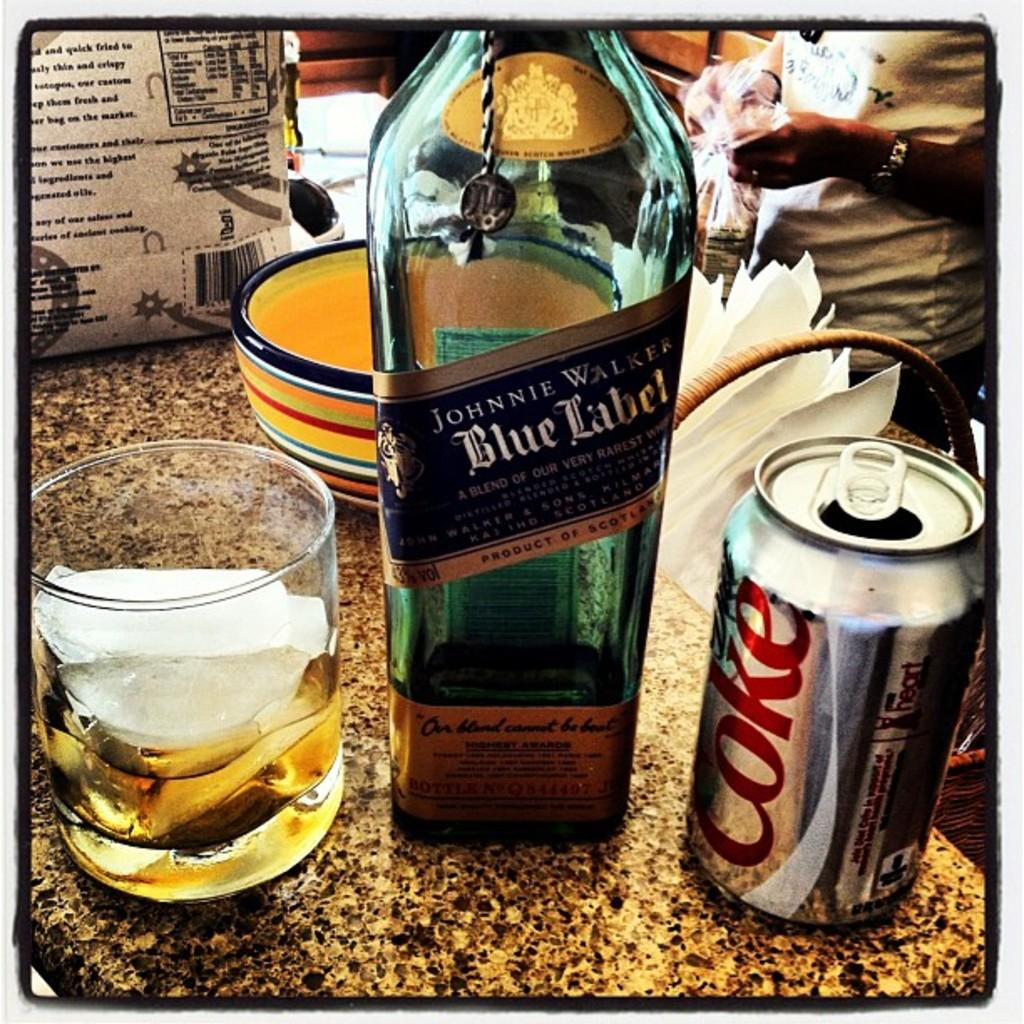<image>
Relay a brief, clear account of the picture shown. Johnnie Walker Blue Label alongside a glass of the whisky mixed with some Coca Cola. 